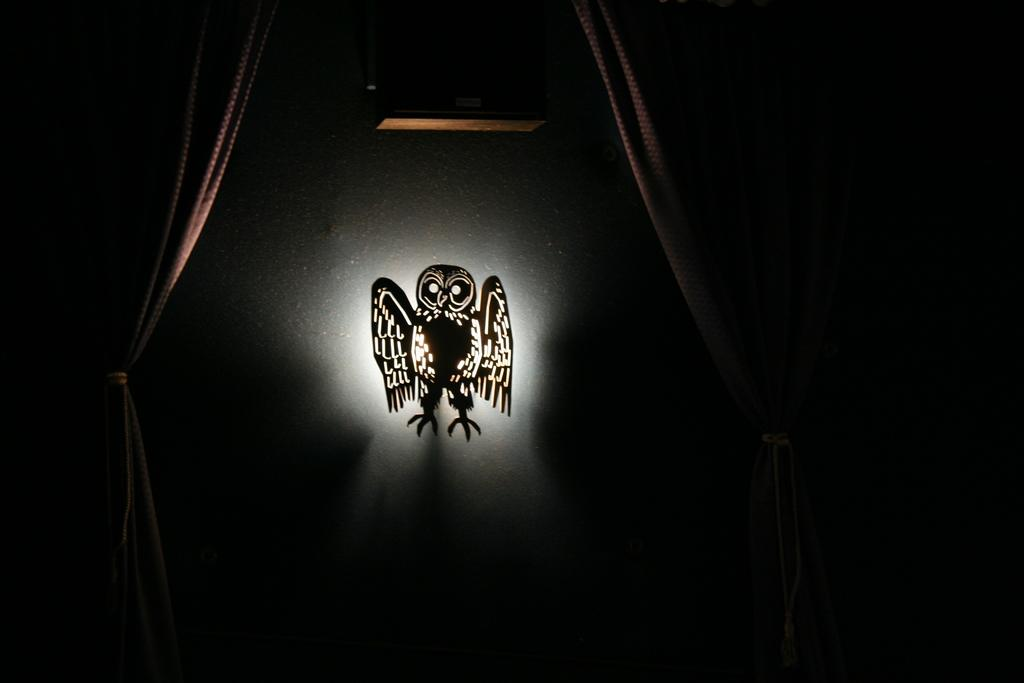What is present on the wall in the image? There is a painting of an owl on the wall in the image. What type of window treatment is visible in the image? There are curtains in the image. Can you describe the wall in the image? The wall has a painting of an owl on it. What type of silver vase can be seen on the wall in the image? There is no silver vase present in the image; it only features a painting of an owl on the wall. How many circles are visible in the image? There is no specific mention of circles in the image, so it is not possible to determine the number of circles present. 